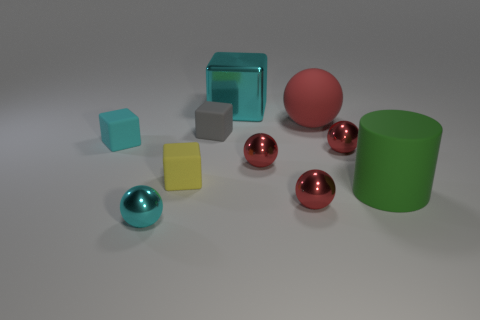Subtract all purple blocks. How many red spheres are left? 4 Subtract all red balls. How many balls are left? 1 Subtract 1 balls. How many balls are left? 4 Subtract all cyan spheres. How many spheres are left? 4 Subtract all cubes. How many objects are left? 6 Subtract all brown spheres. Subtract all blue blocks. How many spheres are left? 5 Add 4 large cylinders. How many large cylinders are left? 5 Add 10 brown shiny things. How many brown shiny things exist? 10 Subtract 0 red cylinders. How many objects are left? 10 Subtract all red rubber objects. Subtract all red spheres. How many objects are left? 5 